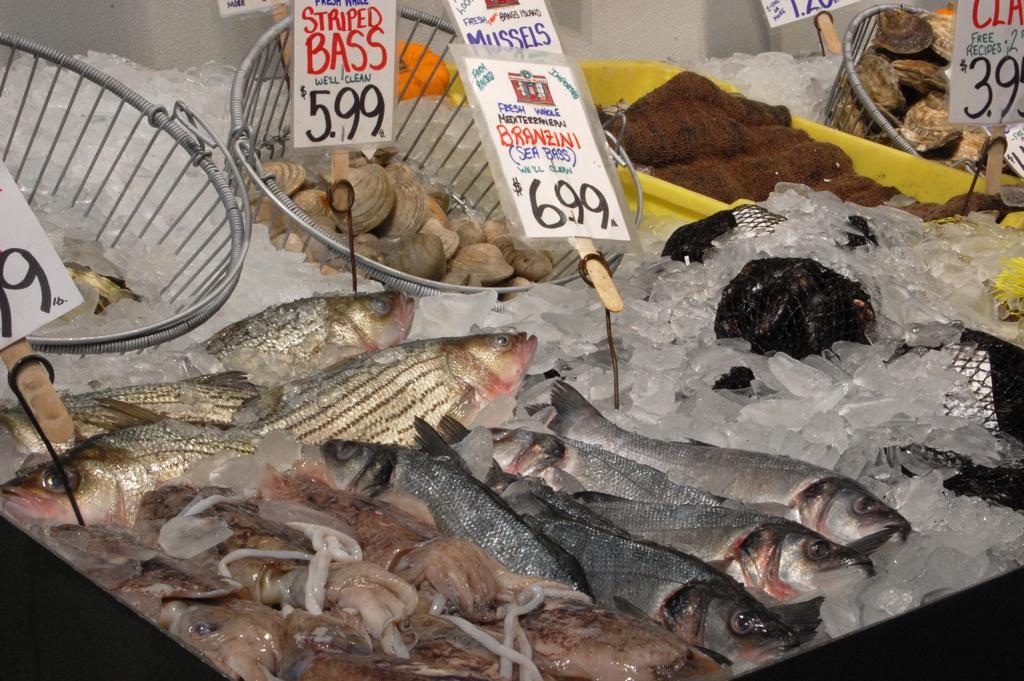Please provide a concise description of this image. In this image we can see containers, basket, price tags, ice pieces, and sea food. 